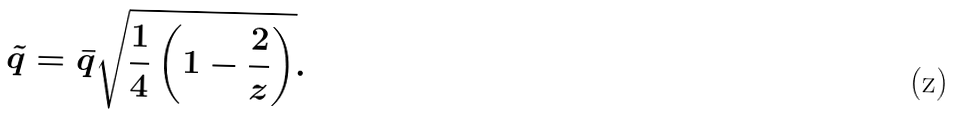<formula> <loc_0><loc_0><loc_500><loc_500>\tilde { q } = \bar { q } \sqrt { \frac { 1 } { 4 } \left ( 1 - \frac { 2 } { z } \right ) } .</formula> 